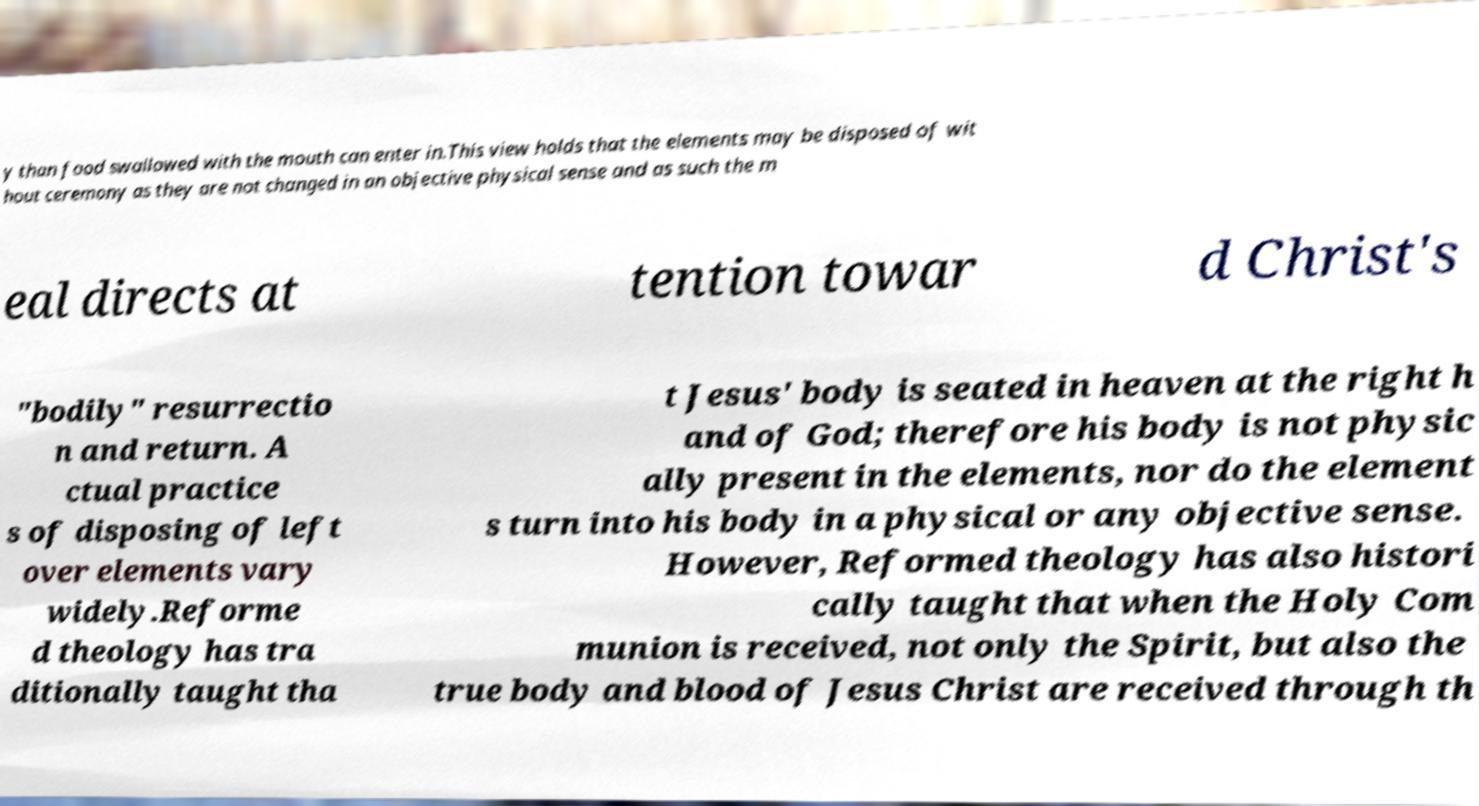There's text embedded in this image that I need extracted. Can you transcribe it verbatim? y than food swallowed with the mouth can enter in.This view holds that the elements may be disposed of wit hout ceremony as they are not changed in an objective physical sense and as such the m eal directs at tention towar d Christ's "bodily" resurrectio n and return. A ctual practice s of disposing of left over elements vary widely.Reforme d theology has tra ditionally taught tha t Jesus' body is seated in heaven at the right h and of God; therefore his body is not physic ally present in the elements, nor do the element s turn into his body in a physical or any objective sense. However, Reformed theology has also histori cally taught that when the Holy Com munion is received, not only the Spirit, but also the true body and blood of Jesus Christ are received through th 